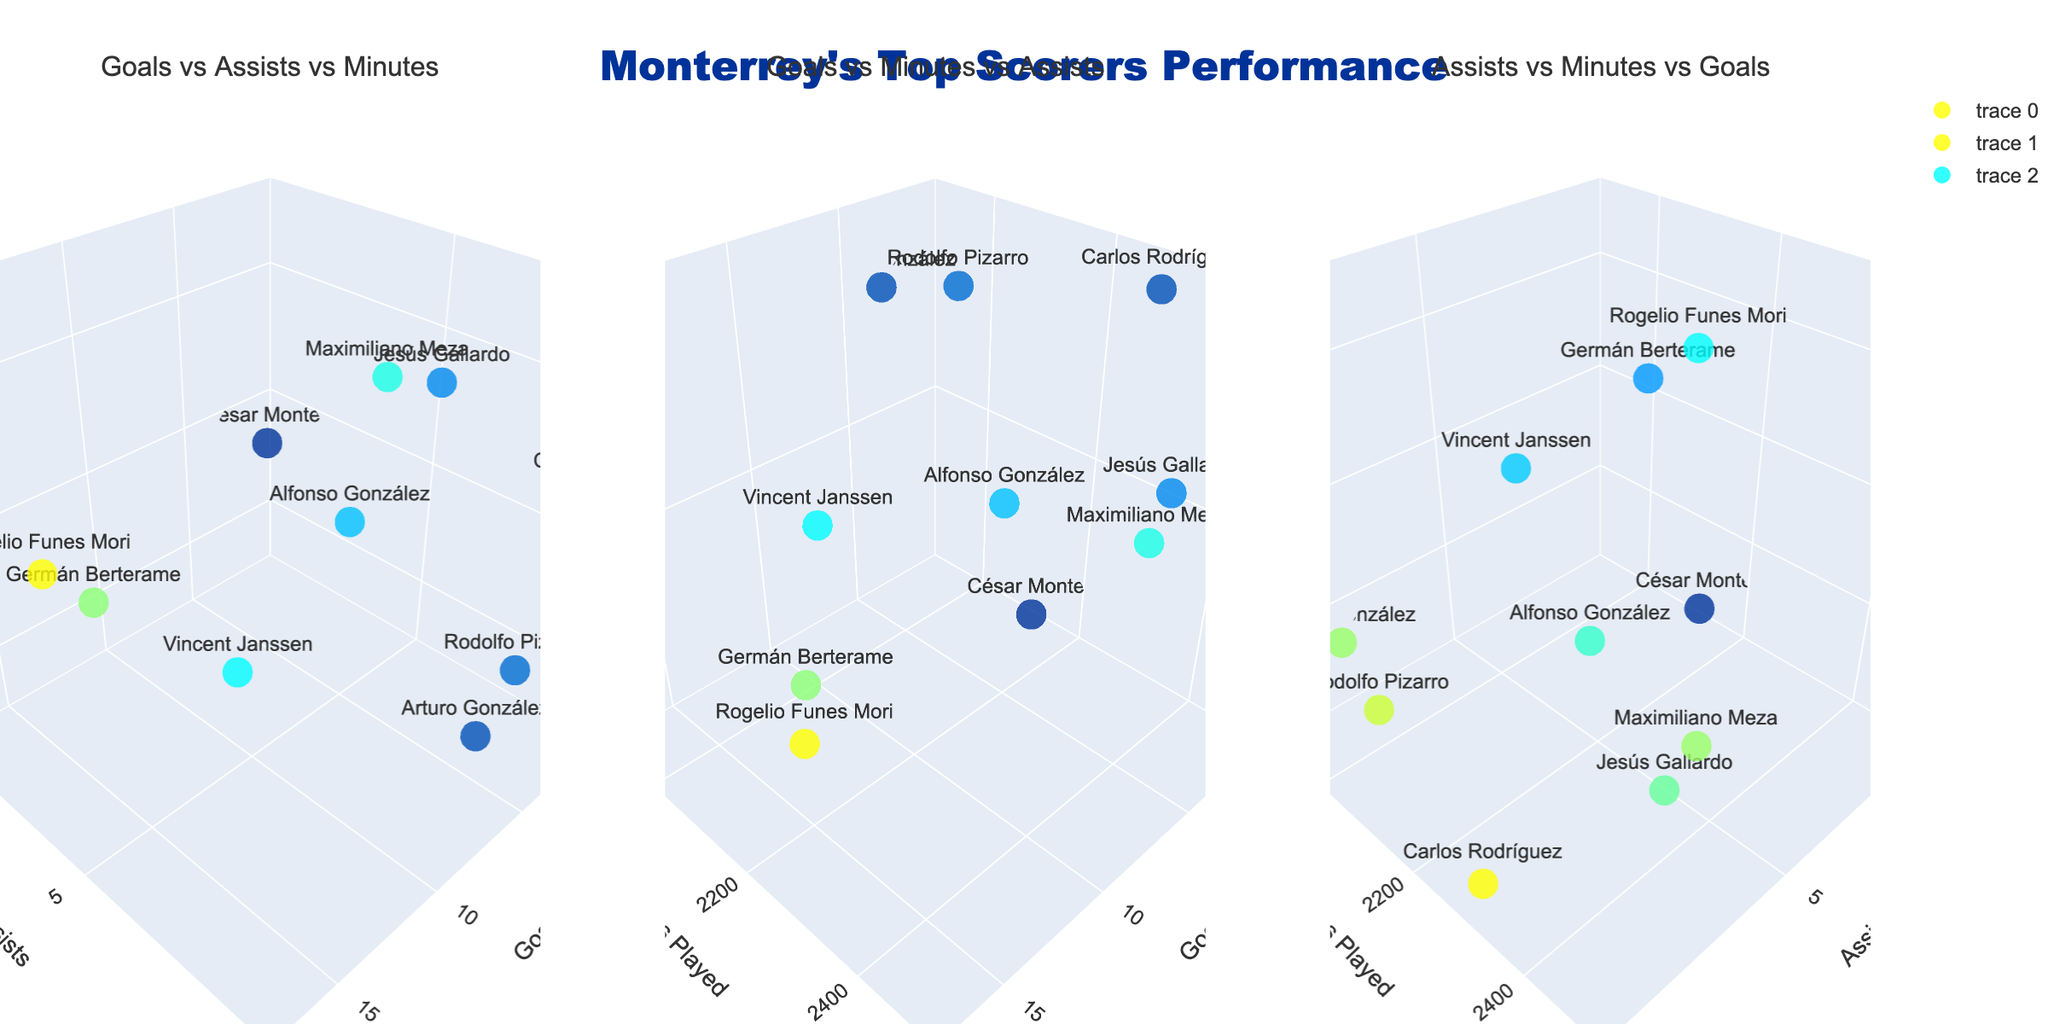what is the title of the figure? The title is written on the top of the figure, centering in a larger font size with specific color and font settings.
Answer: Monterrey's Top Scorers Performance Which player has the highest number of goals? By looking at the subplot titled "Goals vs Assists vs Minutes" or "Goals vs Minutes vs Assists", you can see that Rogelio Funes Mori has the highest number of goals.
Answer: Rogelio Funes Mori How many assists did Arturo González provide? In the first subplot "Goals vs Assists vs Minutes", locate Arturo González's data point and identify the 'Assists' value.
Answer: 8 Which player has more assists, Rodolfo Pizarro or Carlos Rodríguez? In any of the subplots where assists can be identified, compare the assists values of Rodolfo Pizarro and Carlos Rodríguez.
Answer: Carlos Rodríguez What's the sum of goals scored by Vincent Janssen and Jesús Gallardo? Find the number of goals scored by Vincent Janssen and Jesús Gallardo in any subplot with goals as a dimension, then sum them up: 9 (Janssen) + 5 (Gallardo).
Answer: 14 Who played the most minutes? Check any subplot where 'Minutes Played' is a dimension. Maximiliano Meza has the highest 'Minutes Played' value.
Answer: Maximiliano Meza Which player has the lowest number of assists? In subplots "Goals vs Assists vs Minutes" or "Assists vs Minutes vs Goals", identify the player with the smallest assists value.
Answer: César Montes What's the difference in goals between Germán Berterame and Alfonso González? In any subplot featuring goals, subtract the goals of Alfonso González from that of Germán Berterame: 14 - 7.
Answer: 7 Whose minutes played are closest to 2200? Look for the players' data points with 'Minutes Played' around 2200 in any subplot with 'Minutes Played' as a dimension. Germán Berterame with 2160 minutes is the closest.
Answer: Germán Berterame 